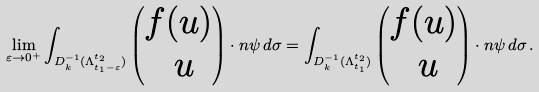Convert formula to latex. <formula><loc_0><loc_0><loc_500><loc_500>\lim _ { \varepsilon \to 0 ^ { + } } \int _ { D _ { k } ^ { - 1 } ( \Lambda _ { t _ { 1 } - \varepsilon } ^ { t _ { 2 } } ) } \begin{pmatrix} f ( u ) \\ \ u \end{pmatrix} \cdot n \psi \, d \sigma = \int _ { D _ { k } ^ { - 1 } ( \Lambda _ { t _ { 1 } } ^ { t _ { 2 } } ) } \begin{pmatrix} f ( u ) \\ \ u \end{pmatrix} \cdot n \psi \, d \sigma \, .</formula> 